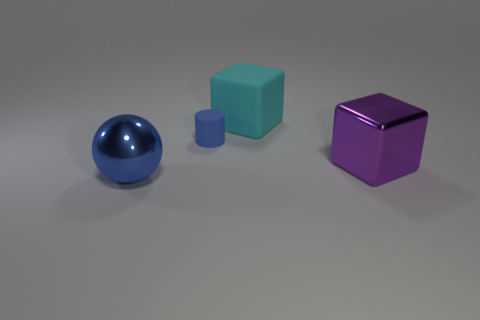Add 3 small matte cylinders. How many objects exist? 7 Subtract all blue rubber cylinders. Subtract all tiny gray shiny balls. How many objects are left? 3 Add 2 large balls. How many large balls are left? 3 Add 3 tiny gray metallic cubes. How many tiny gray metallic cubes exist? 3 Subtract 0 cyan balls. How many objects are left? 4 